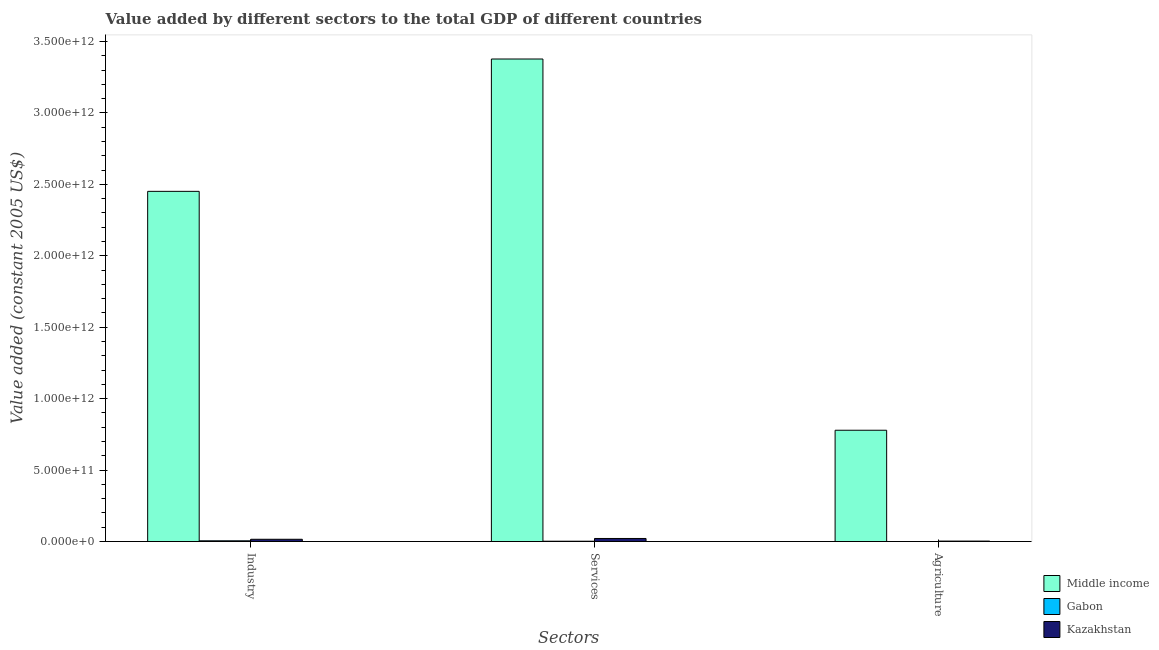How many groups of bars are there?
Ensure brevity in your answer.  3. Are the number of bars per tick equal to the number of legend labels?
Provide a succinct answer. Yes. Are the number of bars on each tick of the X-axis equal?
Give a very brief answer. Yes. How many bars are there on the 3rd tick from the right?
Provide a succinct answer. 3. What is the label of the 3rd group of bars from the left?
Give a very brief answer. Agriculture. What is the value added by services in Kazakhstan?
Make the answer very short. 2.16e+1. Across all countries, what is the maximum value added by services?
Your answer should be compact. 3.38e+12. Across all countries, what is the minimum value added by services?
Provide a succinct answer. 2.48e+09. In which country was the value added by industrial sector minimum?
Your answer should be compact. Gabon. What is the total value added by services in the graph?
Ensure brevity in your answer.  3.40e+12. What is the difference between the value added by agricultural sector in Kazakhstan and that in Gabon?
Your answer should be very brief. 2.89e+09. What is the difference between the value added by industrial sector in Middle income and the value added by agricultural sector in Gabon?
Ensure brevity in your answer.  2.45e+12. What is the average value added by services per country?
Offer a terse response. 1.13e+12. What is the difference between the value added by services and value added by agricultural sector in Gabon?
Keep it short and to the point. 2.05e+09. In how many countries, is the value added by services greater than 600000000000 US$?
Keep it short and to the point. 1. What is the ratio of the value added by industrial sector in Kazakhstan to that in Middle income?
Offer a very short reply. 0.01. What is the difference between the highest and the second highest value added by services?
Your response must be concise. 3.36e+12. What is the difference between the highest and the lowest value added by services?
Your answer should be compact. 3.37e+12. In how many countries, is the value added by services greater than the average value added by services taken over all countries?
Your response must be concise. 1. Is the sum of the value added by services in Middle income and Gabon greater than the maximum value added by agricultural sector across all countries?
Provide a succinct answer. Yes. What does the 3rd bar from the left in Industry represents?
Your response must be concise. Kazakhstan. What is the difference between two consecutive major ticks on the Y-axis?
Keep it short and to the point. 5.00e+11. Where does the legend appear in the graph?
Keep it short and to the point. Bottom right. How are the legend labels stacked?
Keep it short and to the point. Vertical. What is the title of the graph?
Your answer should be compact. Value added by different sectors to the total GDP of different countries. What is the label or title of the X-axis?
Offer a very short reply. Sectors. What is the label or title of the Y-axis?
Your answer should be very brief. Value added (constant 2005 US$). What is the Value added (constant 2005 US$) in Middle income in Industry?
Ensure brevity in your answer.  2.45e+12. What is the Value added (constant 2005 US$) of Gabon in Industry?
Offer a very short reply. 5.31e+09. What is the Value added (constant 2005 US$) of Kazakhstan in Industry?
Offer a very short reply. 1.60e+1. What is the Value added (constant 2005 US$) of Middle income in Services?
Ensure brevity in your answer.  3.38e+12. What is the Value added (constant 2005 US$) of Gabon in Services?
Provide a succinct answer. 2.48e+09. What is the Value added (constant 2005 US$) of Kazakhstan in Services?
Provide a short and direct response. 2.16e+1. What is the Value added (constant 2005 US$) in Middle income in Agriculture?
Offer a very short reply. 7.79e+11. What is the Value added (constant 2005 US$) of Gabon in Agriculture?
Provide a succinct answer. 4.33e+08. What is the Value added (constant 2005 US$) in Kazakhstan in Agriculture?
Provide a succinct answer. 3.33e+09. Across all Sectors, what is the maximum Value added (constant 2005 US$) of Middle income?
Ensure brevity in your answer.  3.38e+12. Across all Sectors, what is the maximum Value added (constant 2005 US$) in Gabon?
Offer a terse response. 5.31e+09. Across all Sectors, what is the maximum Value added (constant 2005 US$) in Kazakhstan?
Your answer should be compact. 2.16e+1. Across all Sectors, what is the minimum Value added (constant 2005 US$) of Middle income?
Give a very brief answer. 7.79e+11. Across all Sectors, what is the minimum Value added (constant 2005 US$) of Gabon?
Your answer should be compact. 4.33e+08. Across all Sectors, what is the minimum Value added (constant 2005 US$) in Kazakhstan?
Your answer should be very brief. 3.33e+09. What is the total Value added (constant 2005 US$) in Middle income in the graph?
Provide a short and direct response. 6.61e+12. What is the total Value added (constant 2005 US$) of Gabon in the graph?
Your answer should be compact. 8.22e+09. What is the total Value added (constant 2005 US$) in Kazakhstan in the graph?
Give a very brief answer. 4.09e+1. What is the difference between the Value added (constant 2005 US$) of Middle income in Industry and that in Services?
Keep it short and to the point. -9.26e+11. What is the difference between the Value added (constant 2005 US$) of Gabon in Industry and that in Services?
Provide a short and direct response. 2.83e+09. What is the difference between the Value added (constant 2005 US$) in Kazakhstan in Industry and that in Services?
Your answer should be compact. -5.58e+09. What is the difference between the Value added (constant 2005 US$) of Middle income in Industry and that in Agriculture?
Your answer should be compact. 1.67e+12. What is the difference between the Value added (constant 2005 US$) of Gabon in Industry and that in Agriculture?
Make the answer very short. 4.87e+09. What is the difference between the Value added (constant 2005 US$) in Kazakhstan in Industry and that in Agriculture?
Your response must be concise. 1.27e+1. What is the difference between the Value added (constant 2005 US$) of Middle income in Services and that in Agriculture?
Offer a very short reply. 2.60e+12. What is the difference between the Value added (constant 2005 US$) in Gabon in Services and that in Agriculture?
Offer a very short reply. 2.05e+09. What is the difference between the Value added (constant 2005 US$) of Kazakhstan in Services and that in Agriculture?
Your response must be concise. 1.82e+1. What is the difference between the Value added (constant 2005 US$) of Middle income in Industry and the Value added (constant 2005 US$) of Gabon in Services?
Your answer should be very brief. 2.45e+12. What is the difference between the Value added (constant 2005 US$) of Middle income in Industry and the Value added (constant 2005 US$) of Kazakhstan in Services?
Ensure brevity in your answer.  2.43e+12. What is the difference between the Value added (constant 2005 US$) in Gabon in Industry and the Value added (constant 2005 US$) in Kazakhstan in Services?
Make the answer very short. -1.63e+1. What is the difference between the Value added (constant 2005 US$) of Middle income in Industry and the Value added (constant 2005 US$) of Gabon in Agriculture?
Offer a very short reply. 2.45e+12. What is the difference between the Value added (constant 2005 US$) of Middle income in Industry and the Value added (constant 2005 US$) of Kazakhstan in Agriculture?
Keep it short and to the point. 2.45e+12. What is the difference between the Value added (constant 2005 US$) in Gabon in Industry and the Value added (constant 2005 US$) in Kazakhstan in Agriculture?
Give a very brief answer. 1.98e+09. What is the difference between the Value added (constant 2005 US$) in Middle income in Services and the Value added (constant 2005 US$) in Gabon in Agriculture?
Offer a terse response. 3.38e+12. What is the difference between the Value added (constant 2005 US$) of Middle income in Services and the Value added (constant 2005 US$) of Kazakhstan in Agriculture?
Your answer should be compact. 3.37e+12. What is the difference between the Value added (constant 2005 US$) of Gabon in Services and the Value added (constant 2005 US$) of Kazakhstan in Agriculture?
Give a very brief answer. -8.45e+08. What is the average Value added (constant 2005 US$) in Middle income per Sectors?
Your answer should be compact. 2.20e+12. What is the average Value added (constant 2005 US$) of Gabon per Sectors?
Provide a succinct answer. 2.74e+09. What is the average Value added (constant 2005 US$) of Kazakhstan per Sectors?
Make the answer very short. 1.36e+1. What is the difference between the Value added (constant 2005 US$) of Middle income and Value added (constant 2005 US$) of Gabon in Industry?
Provide a succinct answer. 2.45e+12. What is the difference between the Value added (constant 2005 US$) in Middle income and Value added (constant 2005 US$) in Kazakhstan in Industry?
Your response must be concise. 2.43e+12. What is the difference between the Value added (constant 2005 US$) of Gabon and Value added (constant 2005 US$) of Kazakhstan in Industry?
Ensure brevity in your answer.  -1.07e+1. What is the difference between the Value added (constant 2005 US$) of Middle income and Value added (constant 2005 US$) of Gabon in Services?
Your answer should be very brief. 3.37e+12. What is the difference between the Value added (constant 2005 US$) of Middle income and Value added (constant 2005 US$) of Kazakhstan in Services?
Offer a terse response. 3.36e+12. What is the difference between the Value added (constant 2005 US$) in Gabon and Value added (constant 2005 US$) in Kazakhstan in Services?
Your answer should be very brief. -1.91e+1. What is the difference between the Value added (constant 2005 US$) of Middle income and Value added (constant 2005 US$) of Gabon in Agriculture?
Keep it short and to the point. 7.79e+11. What is the difference between the Value added (constant 2005 US$) of Middle income and Value added (constant 2005 US$) of Kazakhstan in Agriculture?
Ensure brevity in your answer.  7.76e+11. What is the difference between the Value added (constant 2005 US$) of Gabon and Value added (constant 2005 US$) of Kazakhstan in Agriculture?
Your answer should be very brief. -2.89e+09. What is the ratio of the Value added (constant 2005 US$) in Middle income in Industry to that in Services?
Provide a short and direct response. 0.73. What is the ratio of the Value added (constant 2005 US$) in Gabon in Industry to that in Services?
Ensure brevity in your answer.  2.14. What is the ratio of the Value added (constant 2005 US$) of Kazakhstan in Industry to that in Services?
Keep it short and to the point. 0.74. What is the ratio of the Value added (constant 2005 US$) in Middle income in Industry to that in Agriculture?
Keep it short and to the point. 3.15. What is the ratio of the Value added (constant 2005 US$) of Gabon in Industry to that in Agriculture?
Provide a short and direct response. 12.26. What is the ratio of the Value added (constant 2005 US$) in Kazakhstan in Industry to that in Agriculture?
Your answer should be very brief. 4.8. What is the ratio of the Value added (constant 2005 US$) in Middle income in Services to that in Agriculture?
Your response must be concise. 4.33. What is the ratio of the Value added (constant 2005 US$) in Gabon in Services to that in Agriculture?
Keep it short and to the point. 5.73. What is the ratio of the Value added (constant 2005 US$) in Kazakhstan in Services to that in Agriculture?
Ensure brevity in your answer.  6.48. What is the difference between the highest and the second highest Value added (constant 2005 US$) of Middle income?
Provide a succinct answer. 9.26e+11. What is the difference between the highest and the second highest Value added (constant 2005 US$) of Gabon?
Make the answer very short. 2.83e+09. What is the difference between the highest and the second highest Value added (constant 2005 US$) in Kazakhstan?
Provide a short and direct response. 5.58e+09. What is the difference between the highest and the lowest Value added (constant 2005 US$) of Middle income?
Offer a very short reply. 2.60e+12. What is the difference between the highest and the lowest Value added (constant 2005 US$) in Gabon?
Make the answer very short. 4.87e+09. What is the difference between the highest and the lowest Value added (constant 2005 US$) of Kazakhstan?
Provide a short and direct response. 1.82e+1. 